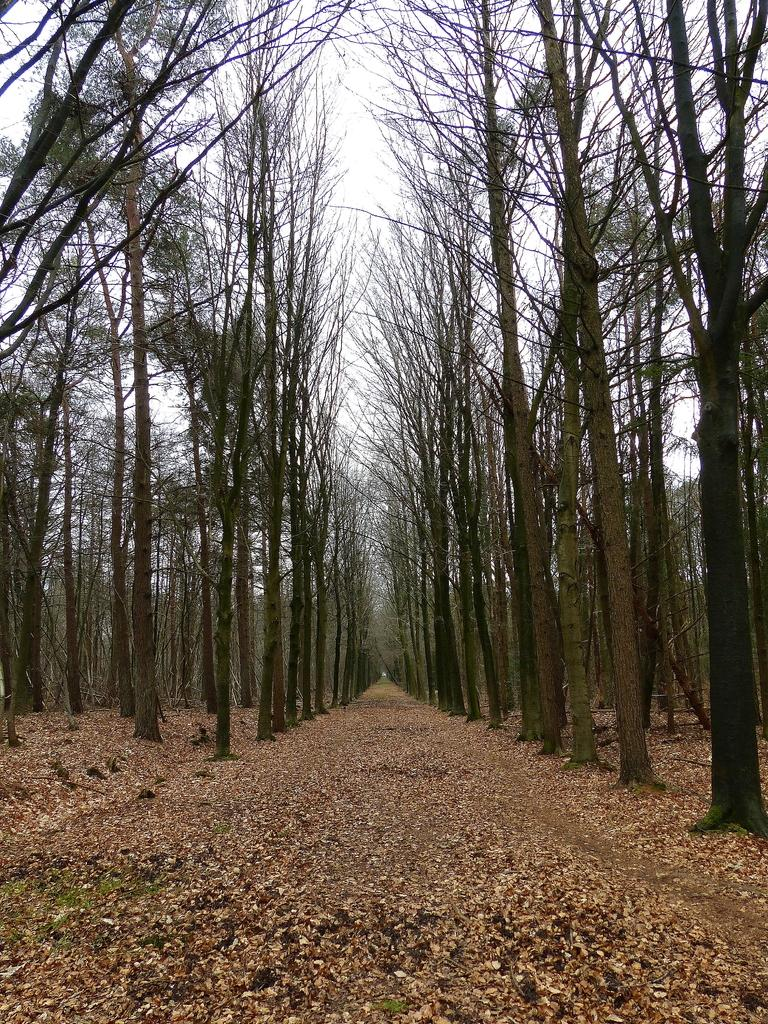What type of surface can be seen in the image? There is ground visible in the image. What is present on the ground in the image? There are leaves on the ground. What type of vegetation is present in the image? There are trees in the image. What is visible in the background of the image? The sky is visible in the background of the image. Where is the chair located in the image? There is no chair present in the image. What note is being played by the stick in the image? There is no stick or note being played in the image. 